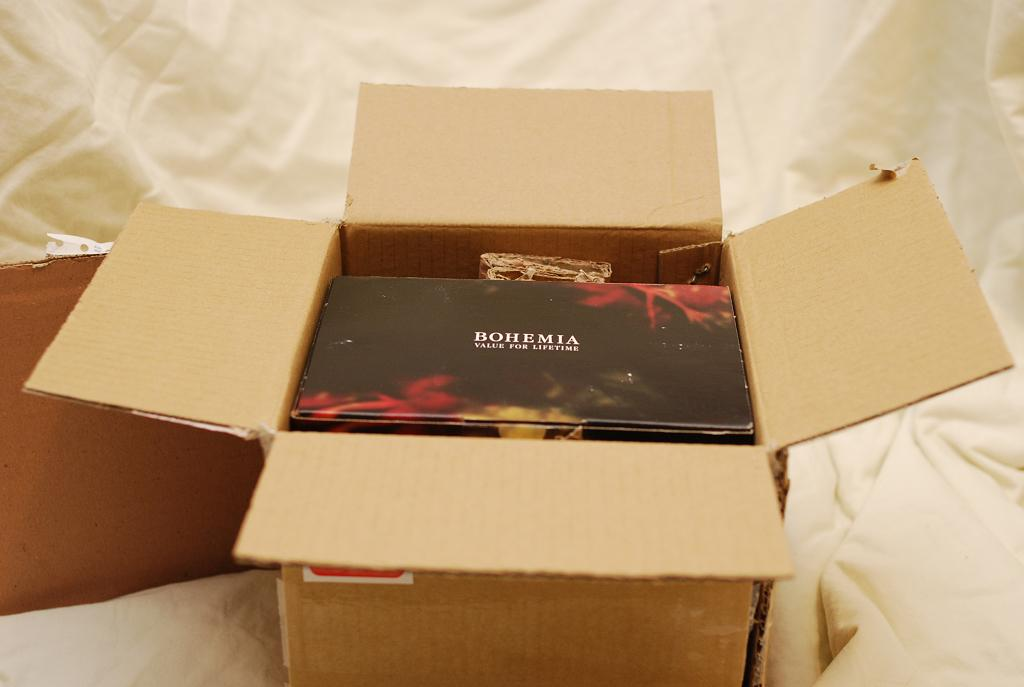<image>
Offer a succinct explanation of the picture presented. An open box contains Bohemia, value for a lifetime. 